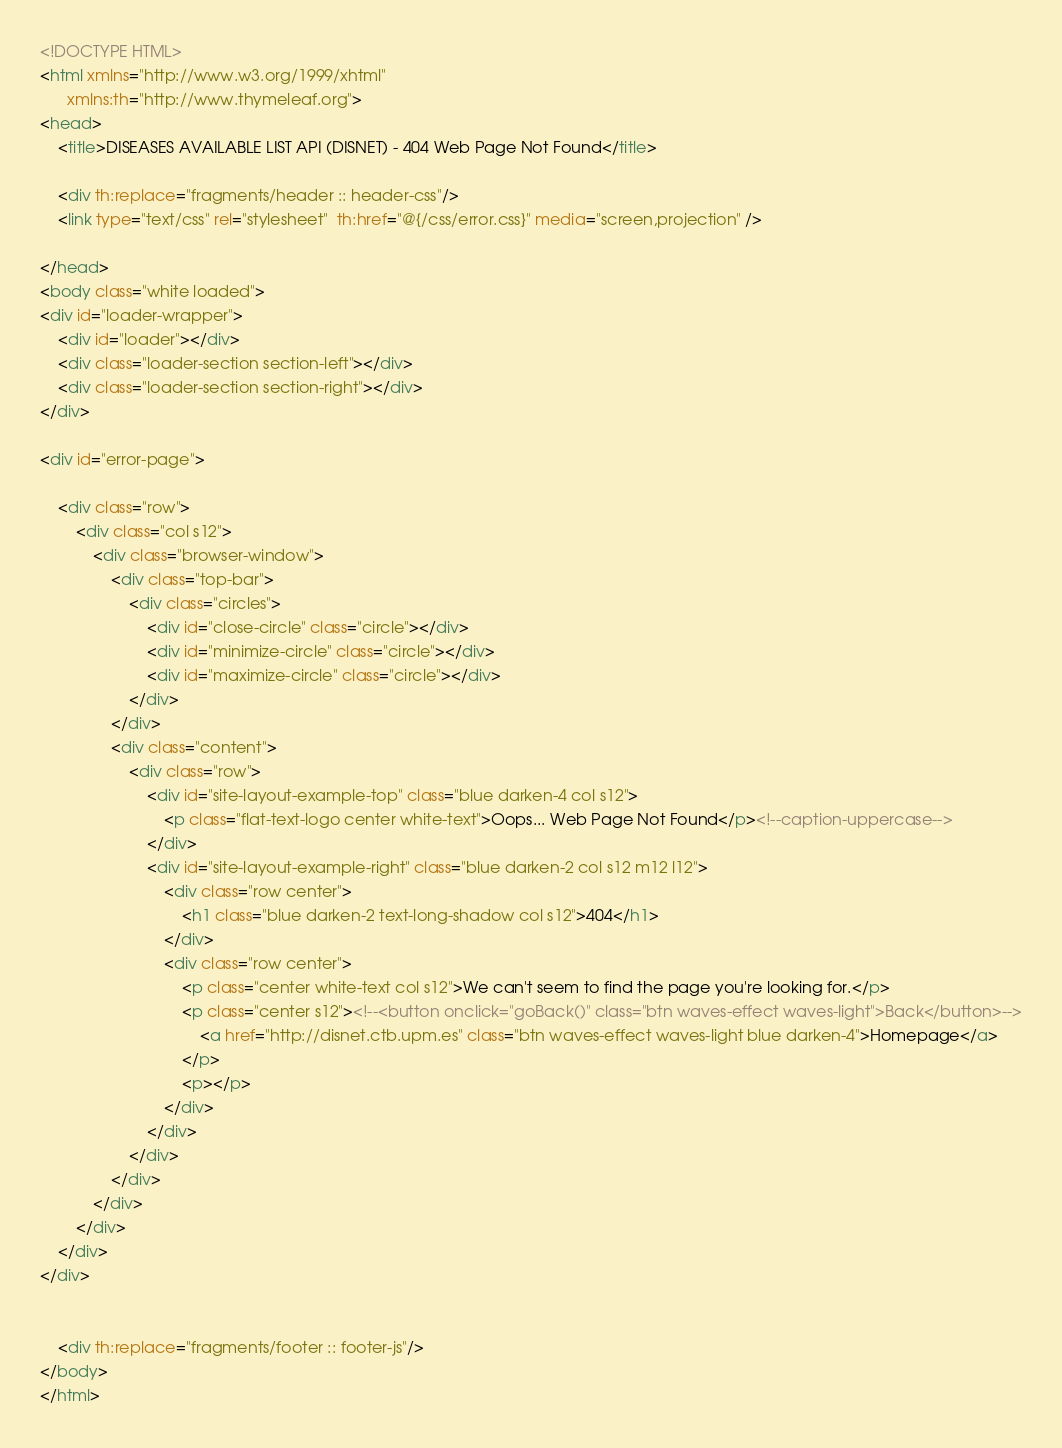<code> <loc_0><loc_0><loc_500><loc_500><_HTML_><!DOCTYPE HTML>
<html xmlns="http://www.w3.org/1999/xhtml"
      xmlns:th="http://www.thymeleaf.org">
<head>
    <title>DISEASES AVAILABLE LIST API (DISNET) - 404 Web Page Not Found</title>

    <div th:replace="fragments/header :: header-css"/>
    <link type="text/css" rel="stylesheet"  th:href="@{/css/error.css}" media="screen,projection" />

</head>
<body class="white loaded">
<div id="loader-wrapper">
    <div id="loader"></div>
    <div class="loader-section section-left"></div>
    <div class="loader-section section-right"></div>
</div>

<div id="error-page">

    <div class="row">
        <div class="col s12">
            <div class="browser-window">
                <div class="top-bar">
                    <div class="circles">
                        <div id="close-circle" class="circle"></div>
                        <div id="minimize-circle" class="circle"></div>
                        <div id="maximize-circle" class="circle"></div>
                    </div>
                </div>
                <div class="content">
                    <div class="row">
                        <div id="site-layout-example-top" class="blue darken-4 col s12">
                            <p class="flat-text-logo center white-text">Oops... Web Page Not Found</p><!--caption-uppercase-->
                        </div>
                        <div id="site-layout-example-right" class="blue darken-2 col s12 m12 l12">
                            <div class="row center">
                                <h1 class="blue darken-2 text-long-shadow col s12">404</h1>
                            </div>
                            <div class="row center">
                                <p class="center white-text col s12">We can't seem to find the page you're looking for.</p>
                                <p class="center s12"><!--<button onclick="goBack()" class="btn waves-effect waves-light">Back</button>-->
                                    <a href="http://disnet.ctb.upm.es" class="btn waves-effect waves-light blue darken-4">Homepage</a>
                                </p>
                                <p></p>
                            </div>
                        </div>
                    </div>
                </div>
            </div>
        </div>
    </div>
</div>


    <div th:replace="fragments/footer :: footer-js"/>
</body>
</html></code> 